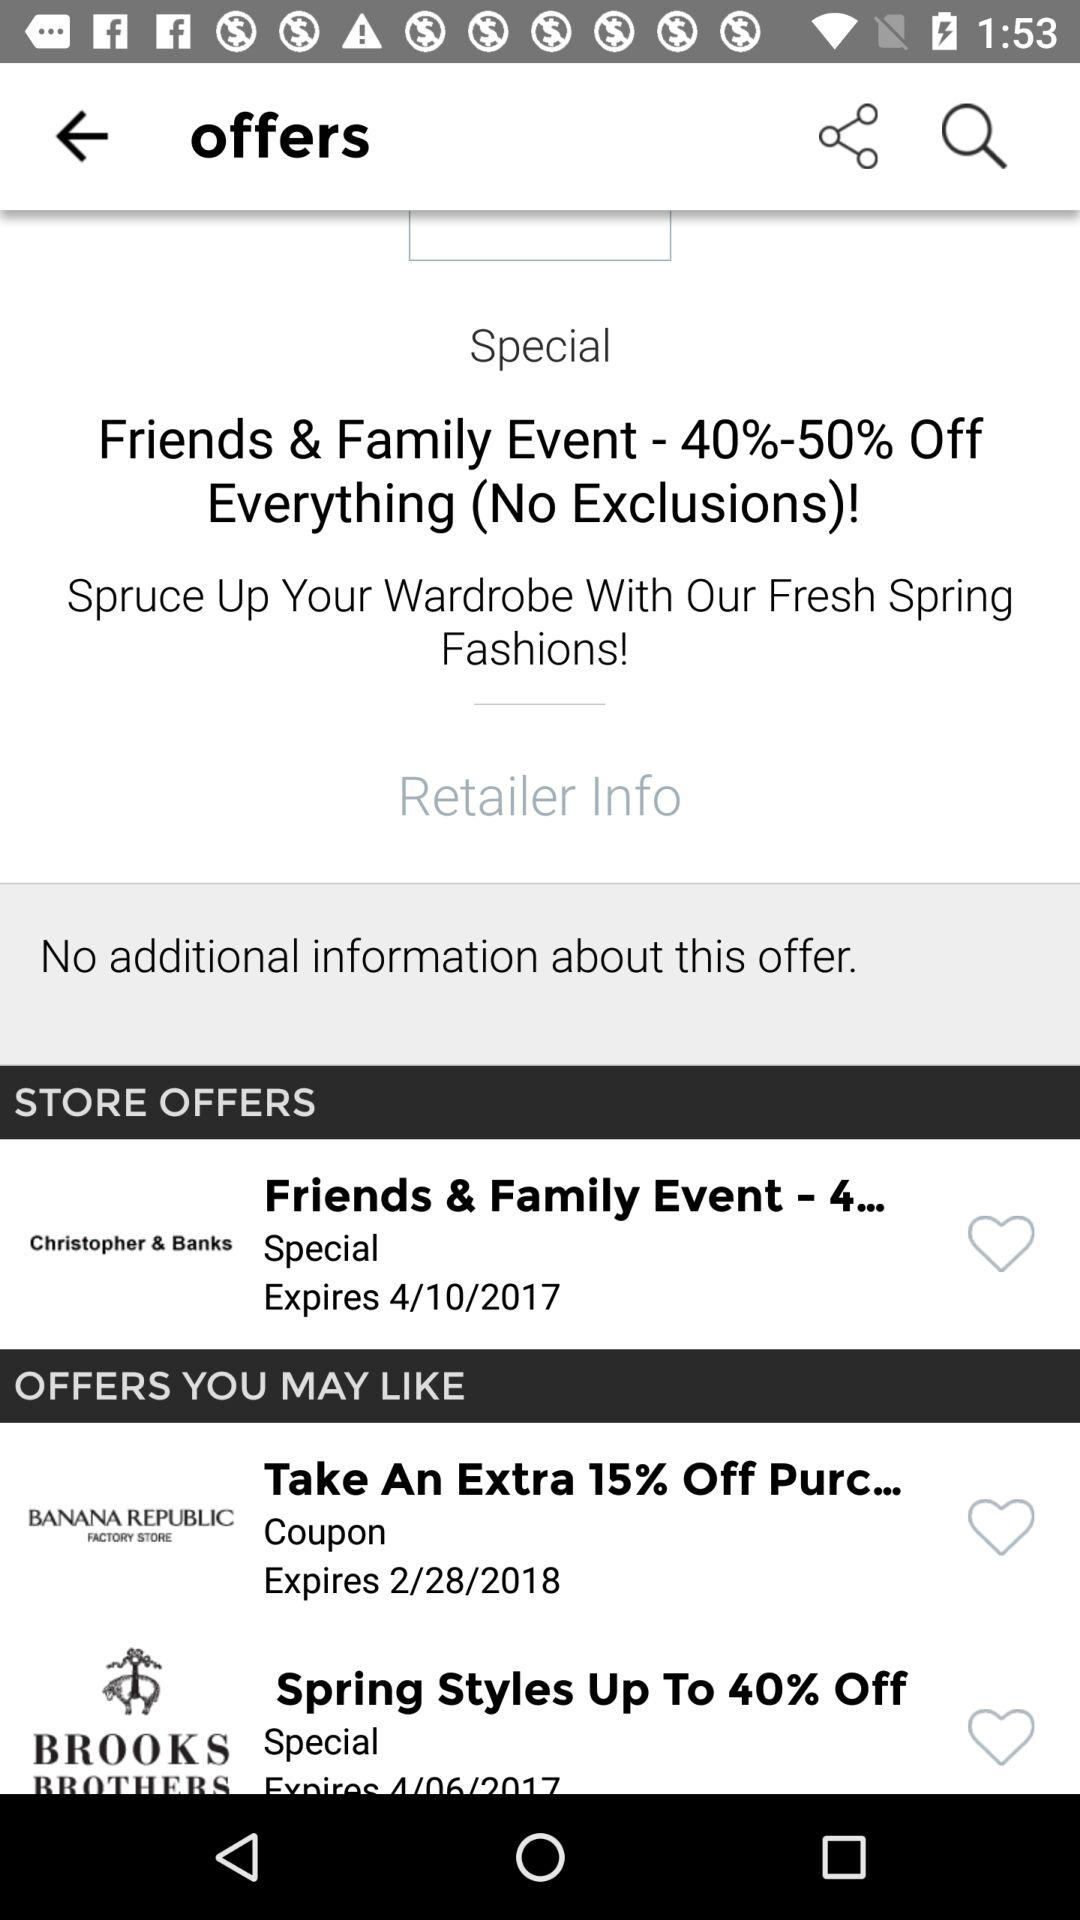What is the expiration date of the coupon in "STORE OFFERS"? The expiration date of the coupon in "STORE OFFERS" is April 10, 2017. 